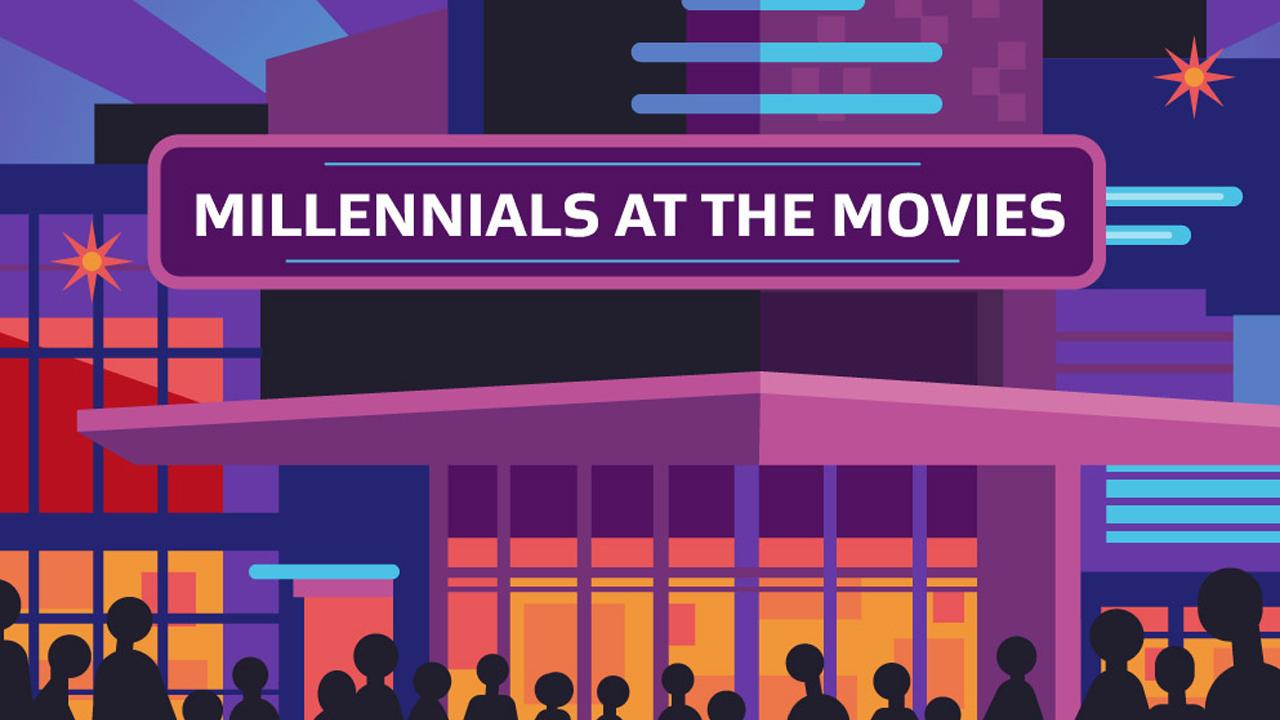Draw attention to some important aspects in this diagram. The color that is predominantly used is purple, not red or blue. The infographic does not contain yellow, green, or blue. The color that is not present in the infographic is green. 